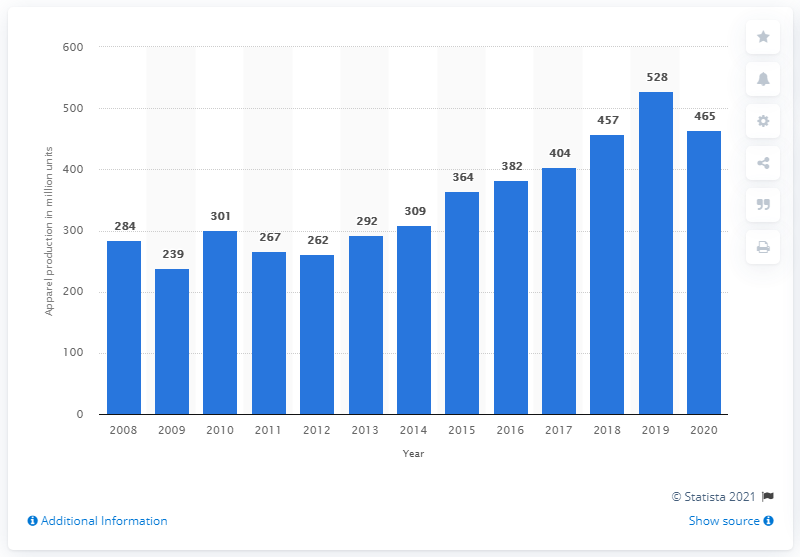Highlight a few significant elements in this photo. In 2020, the adidas Group produced a total of 465 units of apparel. 